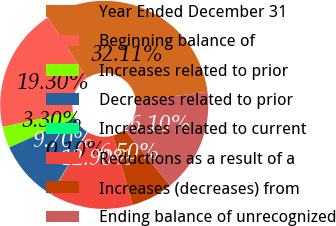<chart> <loc_0><loc_0><loc_500><loc_500><pie_chart><fcel>Year Ended December 31<fcel>Beginning balance of<fcel>Increases related to prior<fcel>Decreases related to prior<fcel>Increases related to current<fcel>Reductions as a result of a<fcel>Increases (decreases) from<fcel>Ending balance of unrecognized<nl><fcel>32.11%<fcel>19.3%<fcel>3.3%<fcel>9.7%<fcel>0.1%<fcel>12.9%<fcel>6.5%<fcel>16.1%<nl></chart> 